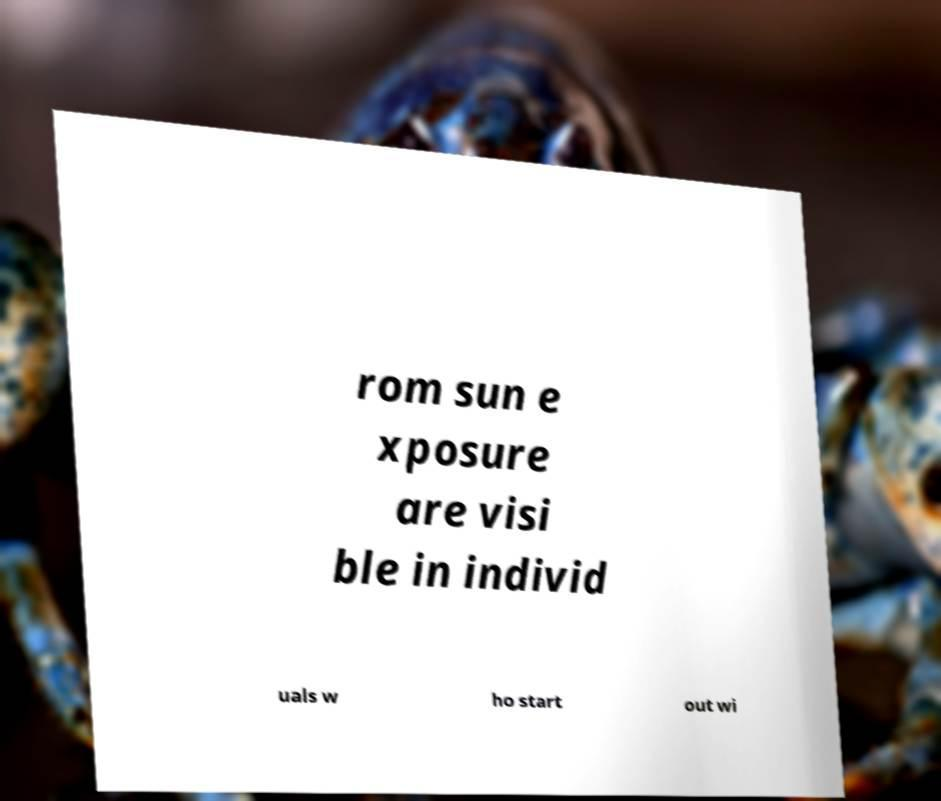What messages or text are displayed in this image? I need them in a readable, typed format. rom sun e xposure are visi ble in individ uals w ho start out wi 